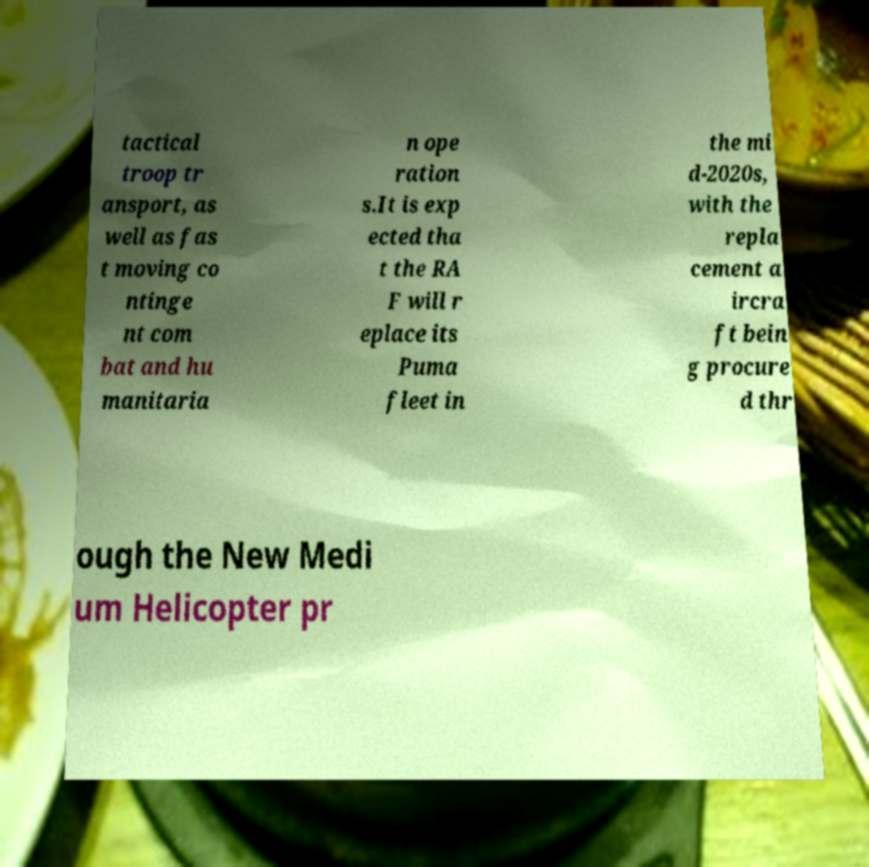For documentation purposes, I need the text within this image transcribed. Could you provide that? tactical troop tr ansport, as well as fas t moving co ntinge nt com bat and hu manitaria n ope ration s.It is exp ected tha t the RA F will r eplace its Puma fleet in the mi d-2020s, with the repla cement a ircra ft bein g procure d thr ough the New Medi um Helicopter pr 